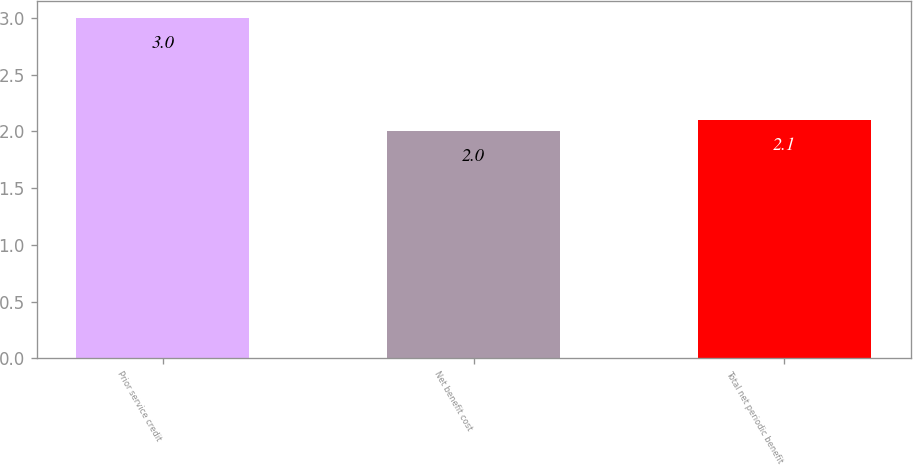Convert chart to OTSL. <chart><loc_0><loc_0><loc_500><loc_500><bar_chart><fcel>Prior service credit<fcel>Net benefit cost<fcel>Total net periodic benefit<nl><fcel>3<fcel>2<fcel>2.1<nl></chart> 